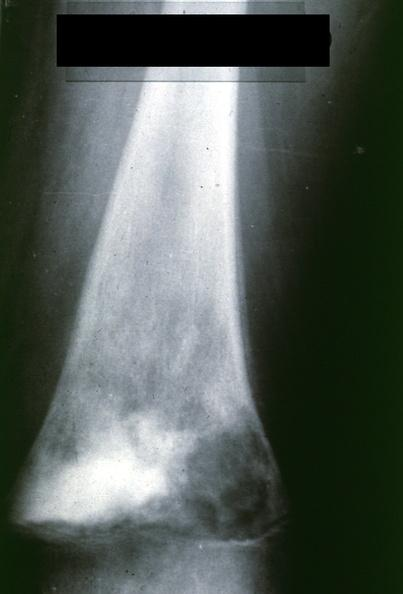s joints present?
Answer the question using a single word or phrase. Yes 